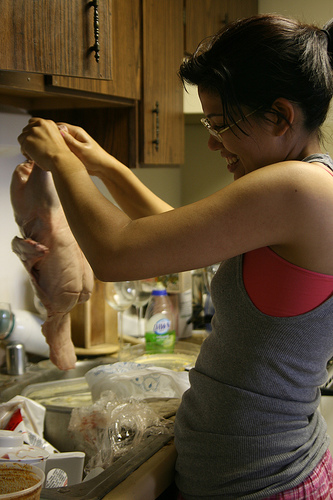<image>
Is the chicken above the sink? Yes. The chicken is positioned above the sink in the vertical space, higher up in the scene. Is the chicken above the woman? No. The chicken is not positioned above the woman. The vertical arrangement shows a different relationship. 